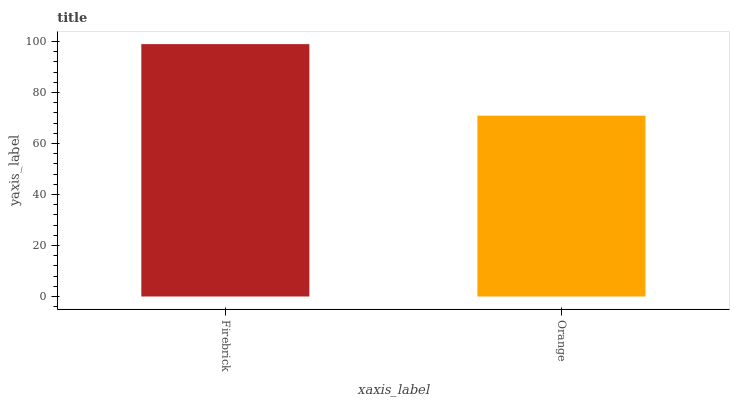Is Orange the maximum?
Answer yes or no. No. Is Firebrick greater than Orange?
Answer yes or no. Yes. Is Orange less than Firebrick?
Answer yes or no. Yes. Is Orange greater than Firebrick?
Answer yes or no. No. Is Firebrick less than Orange?
Answer yes or no. No. Is Firebrick the high median?
Answer yes or no. Yes. Is Orange the low median?
Answer yes or no. Yes. Is Orange the high median?
Answer yes or no. No. Is Firebrick the low median?
Answer yes or no. No. 